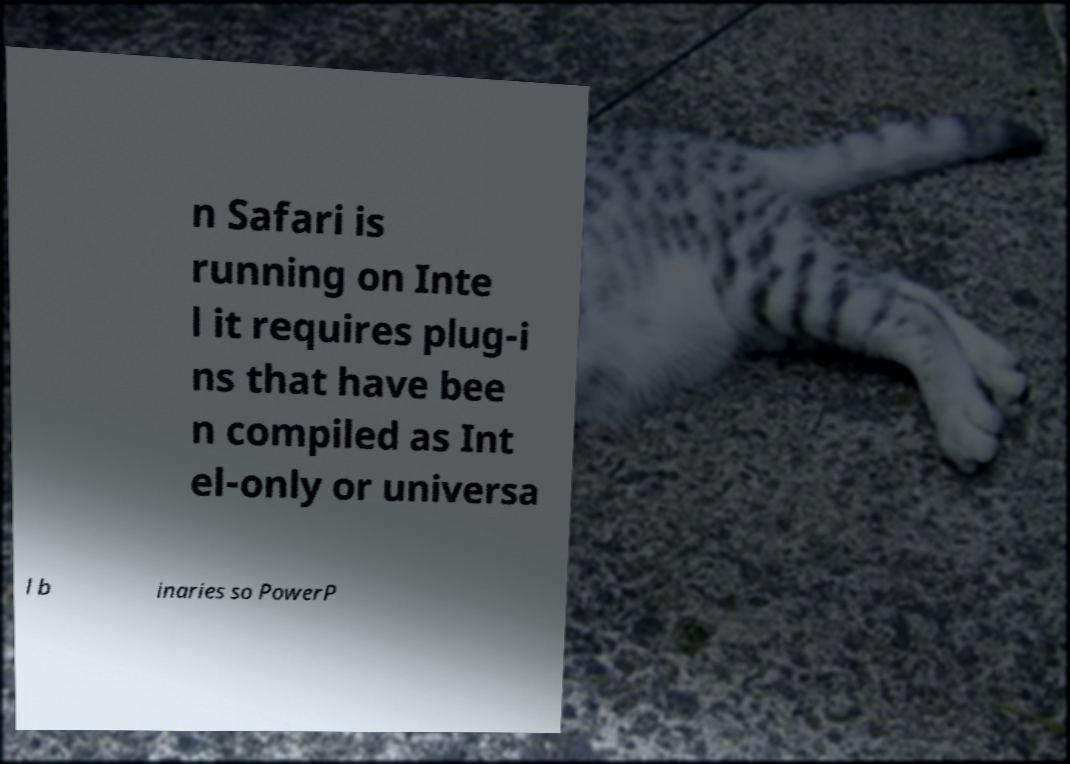For documentation purposes, I need the text within this image transcribed. Could you provide that? n Safari is running on Inte l it requires plug-i ns that have bee n compiled as Int el-only or universa l b inaries so PowerP 